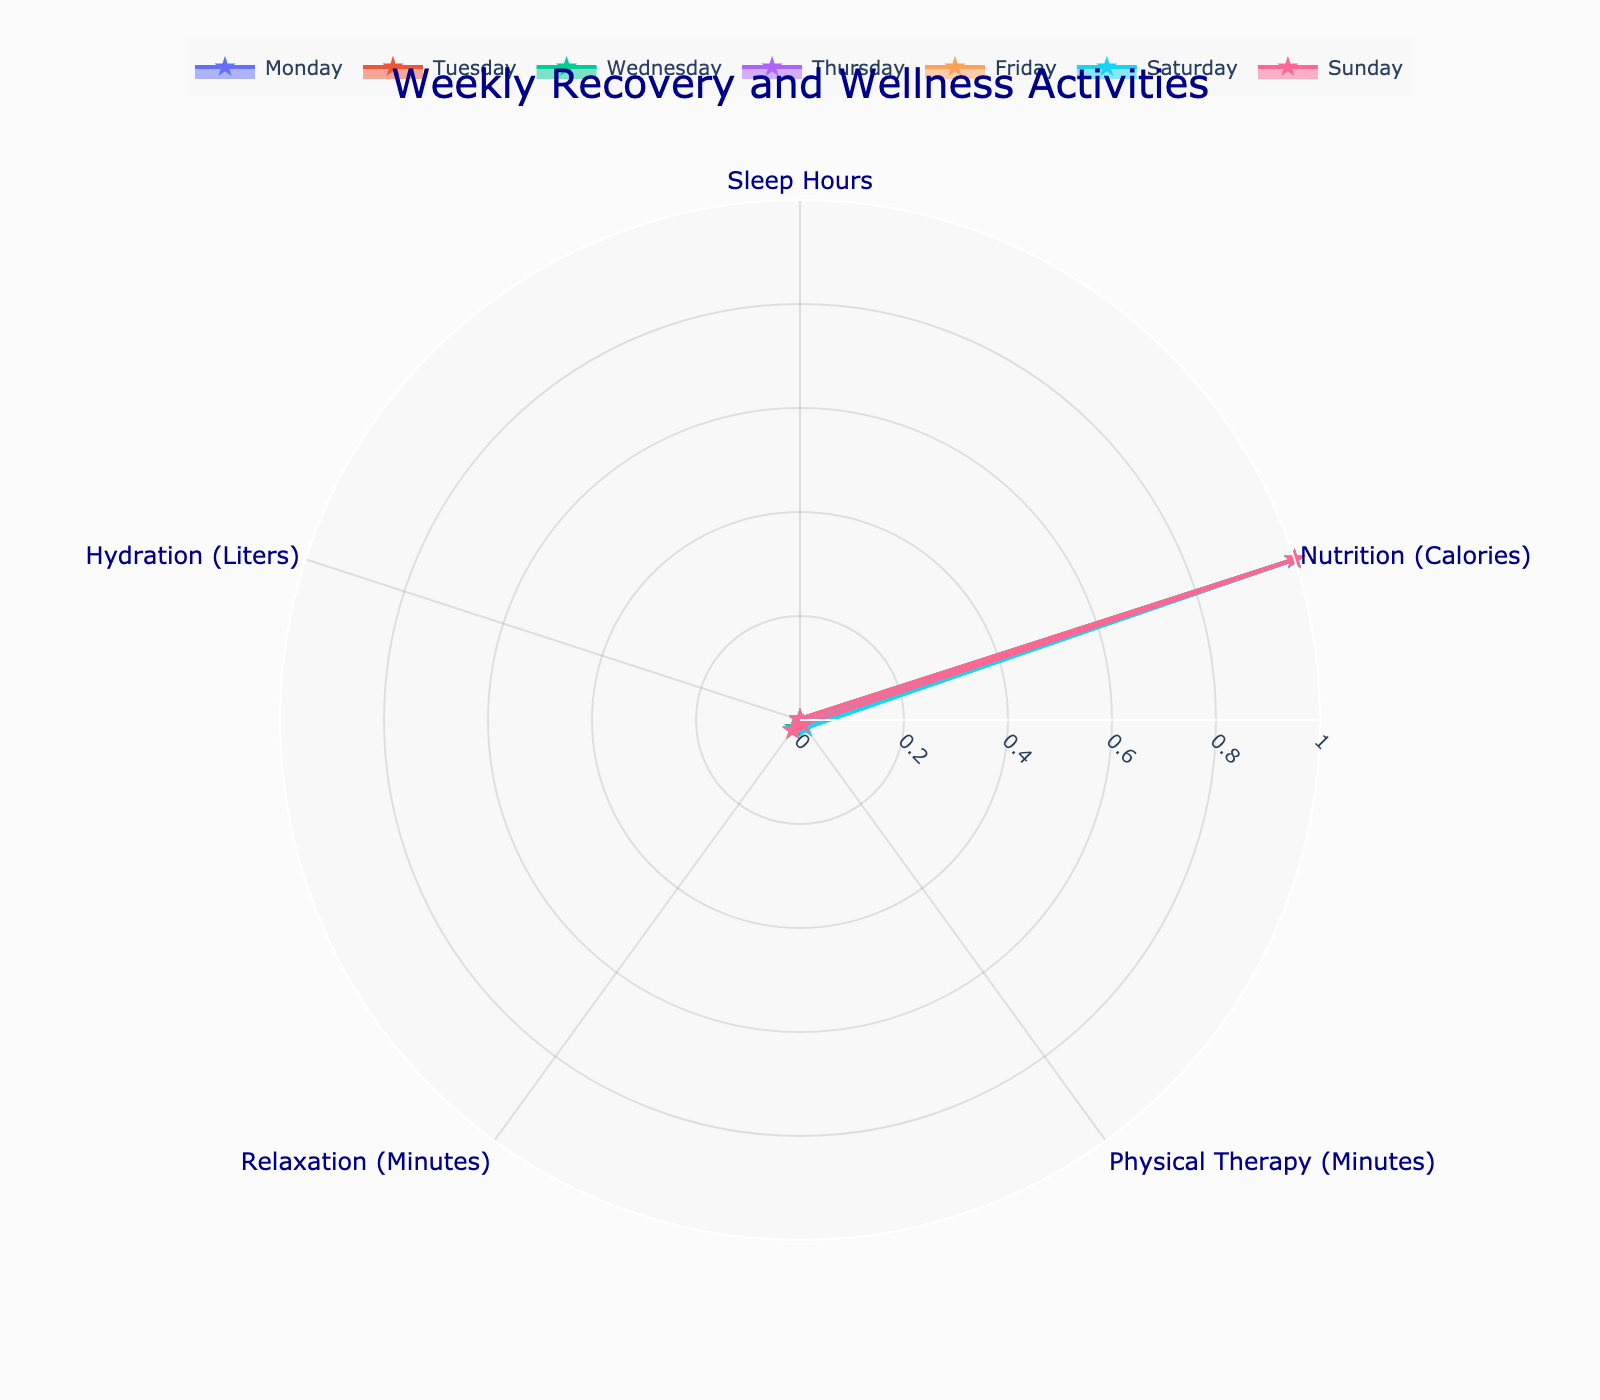What is the title of the polar chart? The title is usually placed at the top of the chart and in this case, it's distinctive in a large font color.
Answer: Weekly Recovery and Wellness Activities Which day has the highest hydration level? To find this, look at the hydration category in the polar chart and identify the day with the largest value.
Answer: Friday Between which two days is the largest difference in physical therapy minutes? Observing the physical therapy category across all days, calculate the difference between the highest and lowest values.
Answer: Saturday and Monday On which day did you get the least sleep? Look at the category for Sleep Hours and find the day with the smallest value.
Answer: Thursday How many categories (activities) are represented in the chart? Each unique segment around the circle represents a category. Counting these gives the total number of activities.
Answer: 5 Which day has the most balanced (closest in values) activities across all categories? This involves comparing the spread of values for each day, looking for the day where the segments are most similar in size.
Answer: Wednesday Calculate the average sleep hours for the week. Add up the sleep hours for all days and then divide by the number of days (7). (8+7+8+6+9+7+8)/7 = 7.57
Answer: 7.57 hours Which category shows the most variation throughout the week? This requires identifying the category with the widest range between its minimum and maximum values when compared across all days.
Answer: Nutrition Compare the hydration levels on Monday and Thursday. Which is higher and by how much? Look at the hydration values for Monday and Thursday and then calculate the difference. Monday: 3, Thursday: 2.8; 3-2.8 = 0.2
Answer: Monday, by 0.2 liters Is there any day when nutrition (calories) intake is below 2500? Reviewing the nutrition section across days, see if any day has a value below 2500.
Answer: Yes, Tuesday and Thursday 